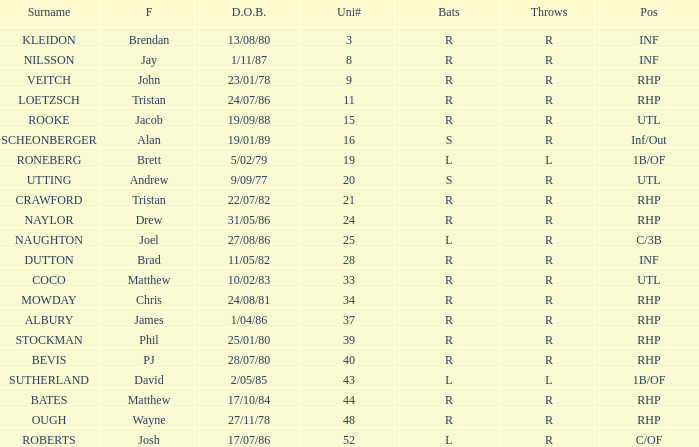Which First has a Uni # larger than 34, and Throws of r, and a Position of rhp, and a Surname of stockman? Phil. 